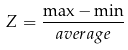<formula> <loc_0><loc_0><loc_500><loc_500>Z = \frac { \max - \min } { a v e r a g e }</formula> 